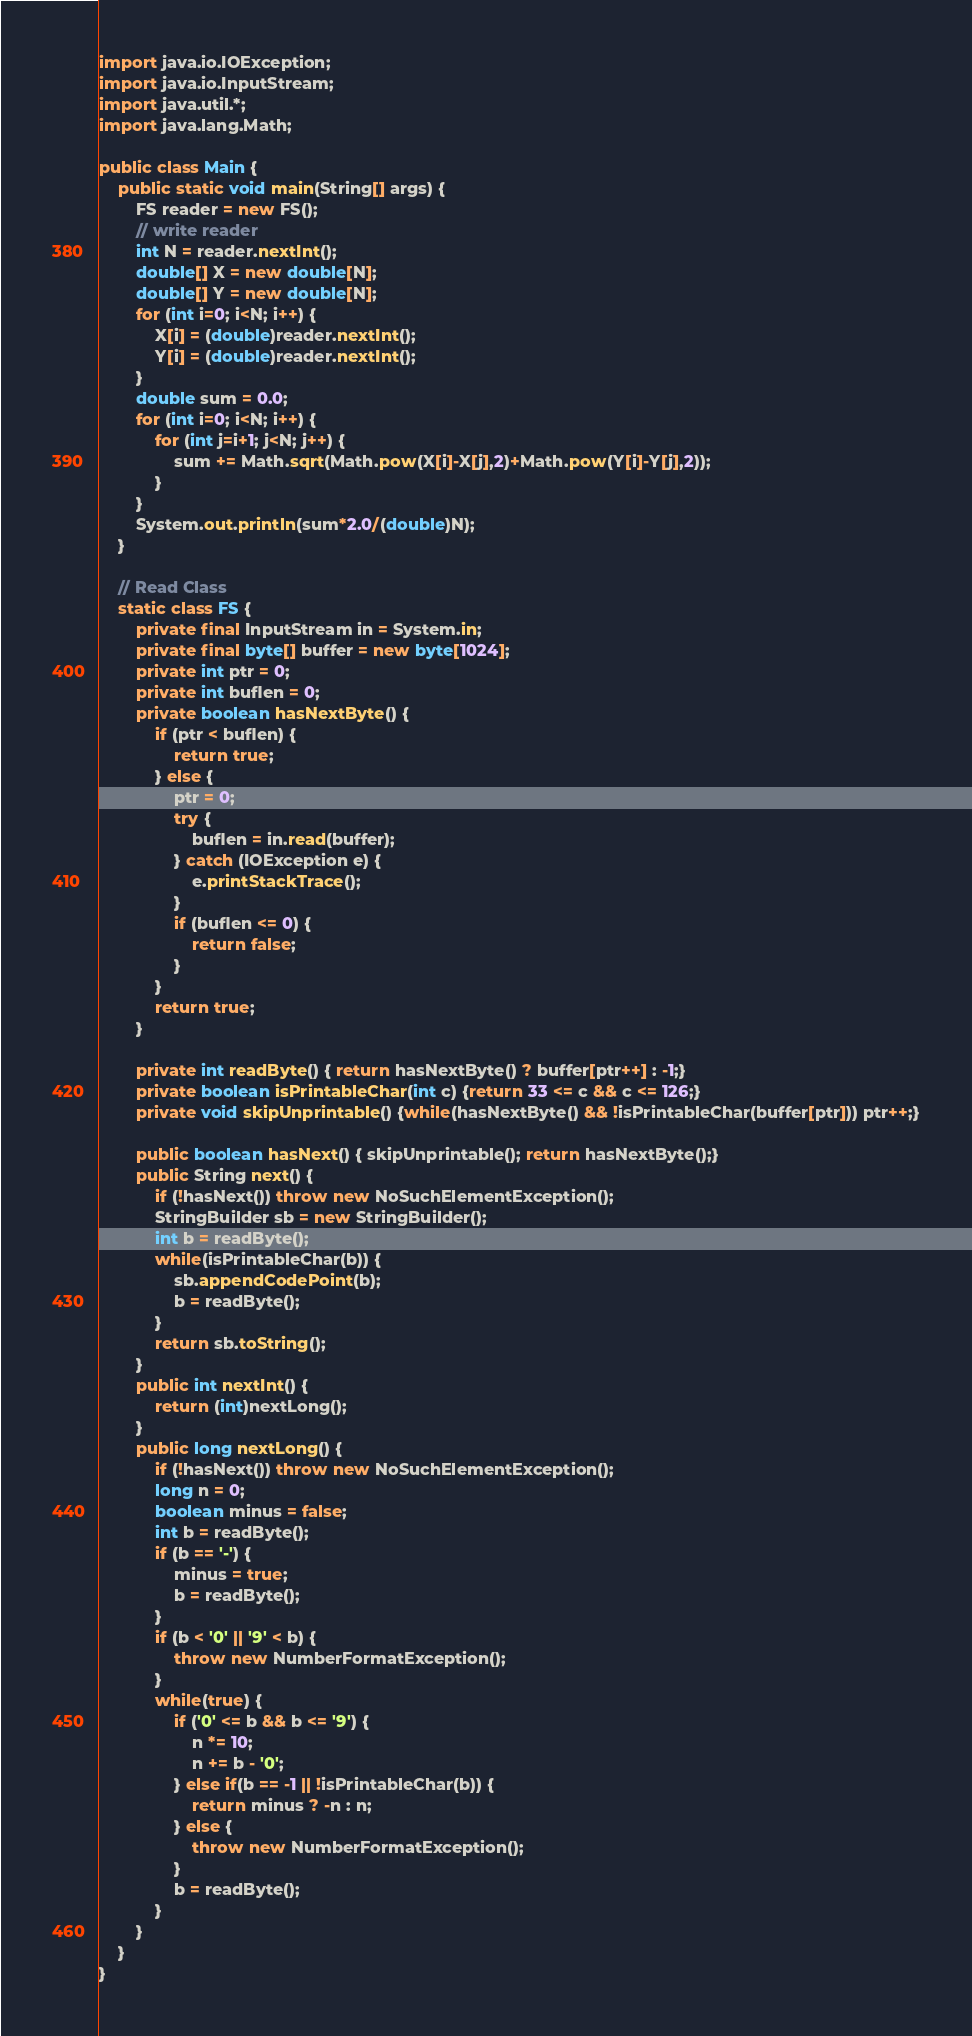Convert code to text. <code><loc_0><loc_0><loc_500><loc_500><_Java_>import java.io.IOException;
import java.io.InputStream;
import java.util.*;
import java.lang.Math;

public class Main {
    public static void main(String[] args) {
        FS reader = new FS();
        // write reader
        int N = reader.nextInt();
        double[] X = new double[N];
        double[] Y = new double[N];
        for (int i=0; i<N; i++) {
            X[i] = (double)reader.nextInt();
            Y[i] = (double)reader.nextInt();
        }
        double sum = 0.0;
        for (int i=0; i<N; i++) {
            for (int j=i+1; j<N; j++) {
                sum += Math.sqrt(Math.pow(X[i]-X[j],2)+Math.pow(Y[i]-Y[j],2));
            }
        }
        System.out.println(sum*2.0/(double)N);
    }

    // Read Class
    static class FS {
        private final InputStream in = System.in;
        private final byte[] buffer = new byte[1024];
        private int ptr = 0;
        private int buflen = 0;
        private boolean hasNextByte() {
            if (ptr < buflen) {
                return true;
            } else {
                ptr = 0;
                try {
                    buflen = in.read(buffer);
                } catch (IOException e) {
                    e.printStackTrace();
                }
                if (buflen <= 0) {
                    return false;
                }
            }
            return true;
        }
    
        private int readByte() { return hasNextByte() ? buffer[ptr++] : -1;}
        private boolean isPrintableChar(int c) {return 33 <= c && c <= 126;}
        private void skipUnprintable() {while(hasNextByte() && !isPrintableChar(buffer[ptr])) ptr++;}
    
        public boolean hasNext() { skipUnprintable(); return hasNextByte();}
        public String next() {
            if (!hasNext()) throw new NoSuchElementException();
            StringBuilder sb = new StringBuilder();
            int b = readByte();
            while(isPrintableChar(b)) {
                sb.appendCodePoint(b);
                b = readByte();
            }
            return sb.toString();
        }
        public int nextInt() {
            return (int)nextLong();
        }
        public long nextLong() {
            if (!hasNext()) throw new NoSuchElementException();
            long n = 0;
            boolean minus = false;
            int b = readByte();
            if (b == '-') {
                minus = true;
                b = readByte();
            }
            if (b < '0' || '9' < b) {
                throw new NumberFormatException();
            }
            while(true) {
                if ('0' <= b && b <= '9') {
                    n *= 10;
                    n += b - '0';
                } else if(b == -1 || !isPrintableChar(b)) {
                    return minus ? -n : n;
                } else {
                    throw new NumberFormatException();
                }
                b = readByte();
            }
        }
    }
}

</code> 